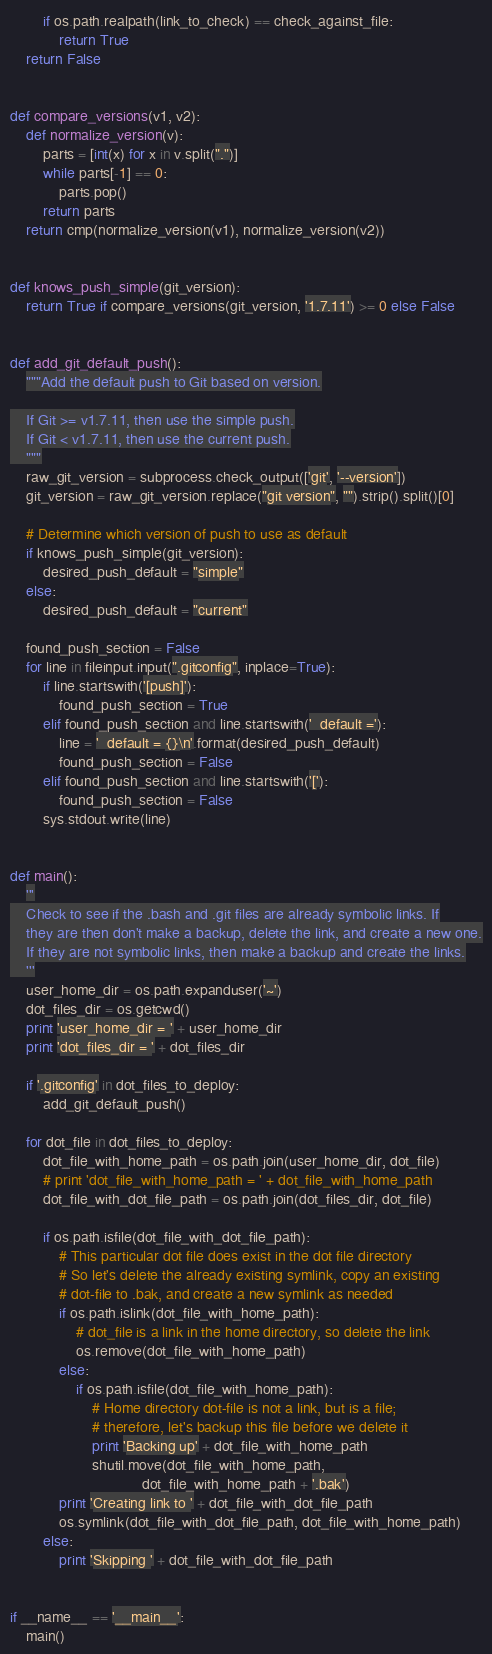Convert code to text. <code><loc_0><loc_0><loc_500><loc_500><_Python_>        if os.path.realpath(link_to_check) == check_against_file:
            return True
    return False


def compare_versions(v1, v2):
    def normalize_version(v):
        parts = [int(x) for x in v.split(".")]
        while parts[-1] == 0:
            parts.pop()
        return parts
    return cmp(normalize_version(v1), normalize_version(v2))


def knows_push_simple(git_version):
    return True if compare_versions(git_version, '1.7.11') >= 0 else False


def add_git_default_push():
    """Add the default push to Git based on version.

    If Git >= v1.7.11, then use the simple push.
    If Git < v1.7.11, then use the current push.
    """
    raw_git_version = subprocess.check_output(['git', '--version'])
    git_version = raw_git_version.replace("git version", "").strip().split()[0]

    # Determine which version of push to use as default
    if knows_push_simple(git_version):
        desired_push_default = "simple"
    else:
        desired_push_default = "current"

    found_push_section = False
    for line in fileinput.input(".gitconfig", inplace=True):
        if line.startswith('[push]'):
            found_push_section = True
        elif found_push_section and line.startswith('  default ='):
            line = '  default = {}\n'.format(desired_push_default)
            found_push_section = False
        elif found_push_section and line.startswith('['):
            found_push_section = False
        sys.stdout.write(line)


def main():
    '''
    Check to see if the .bash and .git files are already symbolic links. If
    they are then don't make a backup, delete the link, and create a new one.
    If they are not symbolic links, then make a backup and create the links.
    '''
    user_home_dir = os.path.expanduser('~')
    dot_files_dir = os.getcwd()
    print 'user_home_dir = ' + user_home_dir
    print 'dot_files_dir = ' + dot_files_dir

    if '.gitconfig' in dot_files_to_deploy:
        add_git_default_push()

    for dot_file in dot_files_to_deploy:
        dot_file_with_home_path = os.path.join(user_home_dir, dot_file)
        # print 'dot_file_with_home_path = ' + dot_file_with_home_path
        dot_file_with_dot_file_path = os.path.join(dot_files_dir, dot_file)

        if os.path.isfile(dot_file_with_dot_file_path):
            # This particular dot file does exist in the dot file directory
            # So let's delete the already existing symlink, copy an existing
            # dot-file to .bak, and create a new symlink as needed
            if os.path.islink(dot_file_with_home_path):
                # dot_file is a link in the home directory, so delete the link
                os.remove(dot_file_with_home_path)
            else:
                if os.path.isfile(dot_file_with_home_path):
                    # Home directory dot-file is not a link, but is a file;
                    # therefore, let's backup this file before we delete it
                    print 'Backing up' + dot_file_with_home_path
                    shutil.move(dot_file_with_home_path,
                                dot_file_with_home_path + '.bak')
            print 'Creating link to ' + dot_file_with_dot_file_path
            os.symlink(dot_file_with_dot_file_path, dot_file_with_home_path)
        else:
            print 'Skipping ' + dot_file_with_dot_file_path


if __name__ == '__main__':
    main()
</code> 